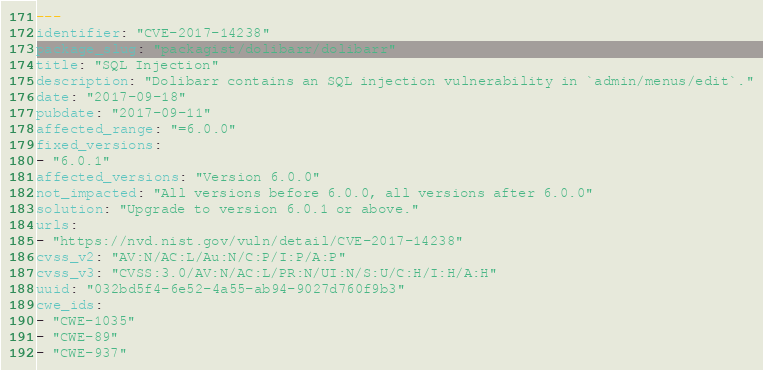Convert code to text. <code><loc_0><loc_0><loc_500><loc_500><_YAML_>---
identifier: "CVE-2017-14238"
package_slug: "packagist/dolibarr/dolibarr"
title: "SQL Injection"
description: "Dolibarr contains an SQL injection vulnerability in `admin/menus/edit`."
date: "2017-09-18"
pubdate: "2017-09-11"
affected_range: "=6.0.0"
fixed_versions:
- "6.0.1"
affected_versions: "Version 6.0.0"
not_impacted: "All versions before 6.0.0, all versions after 6.0.0"
solution: "Upgrade to version 6.0.1 or above."
urls:
- "https://nvd.nist.gov/vuln/detail/CVE-2017-14238"
cvss_v2: "AV:N/AC:L/Au:N/C:P/I:P/A:P"
cvss_v3: "CVSS:3.0/AV:N/AC:L/PR:N/UI:N/S:U/C:H/I:H/A:H"
uuid: "032bd5f4-6e52-4a55-ab94-9027d760f9b3"
cwe_ids:
- "CWE-1035"
- "CWE-89"
- "CWE-937"
</code> 